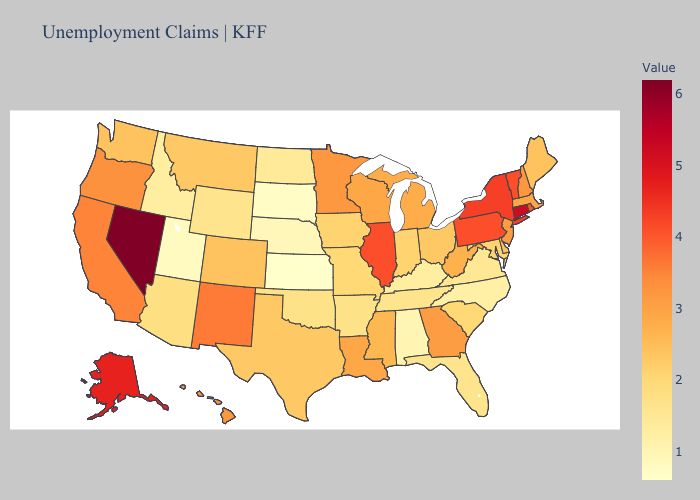Among the states that border Wisconsin , does Illinois have the lowest value?
Be succinct. No. Does Michigan have a lower value than Virginia?
Concise answer only. No. Does Massachusetts have a lower value than Connecticut?
Be succinct. Yes. Does the map have missing data?
Keep it brief. No. Which states have the highest value in the USA?
Be succinct. Nevada. 